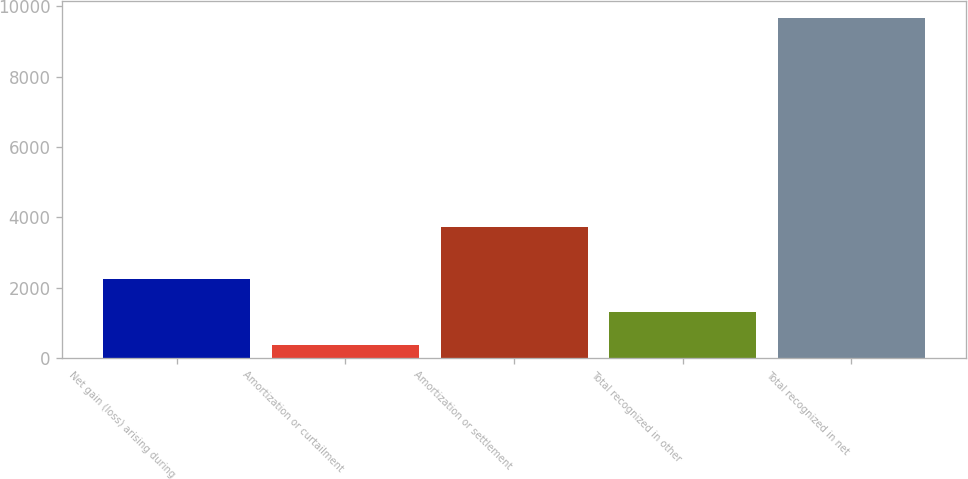Convert chart to OTSL. <chart><loc_0><loc_0><loc_500><loc_500><bar_chart><fcel>Net gain (loss) arising during<fcel>Amortization or curtailment<fcel>Amortization or settlement<fcel>Total recognized in other<fcel>Total recognized in net<nl><fcel>2235.4<fcel>376<fcel>3729<fcel>1305.7<fcel>9673<nl></chart> 